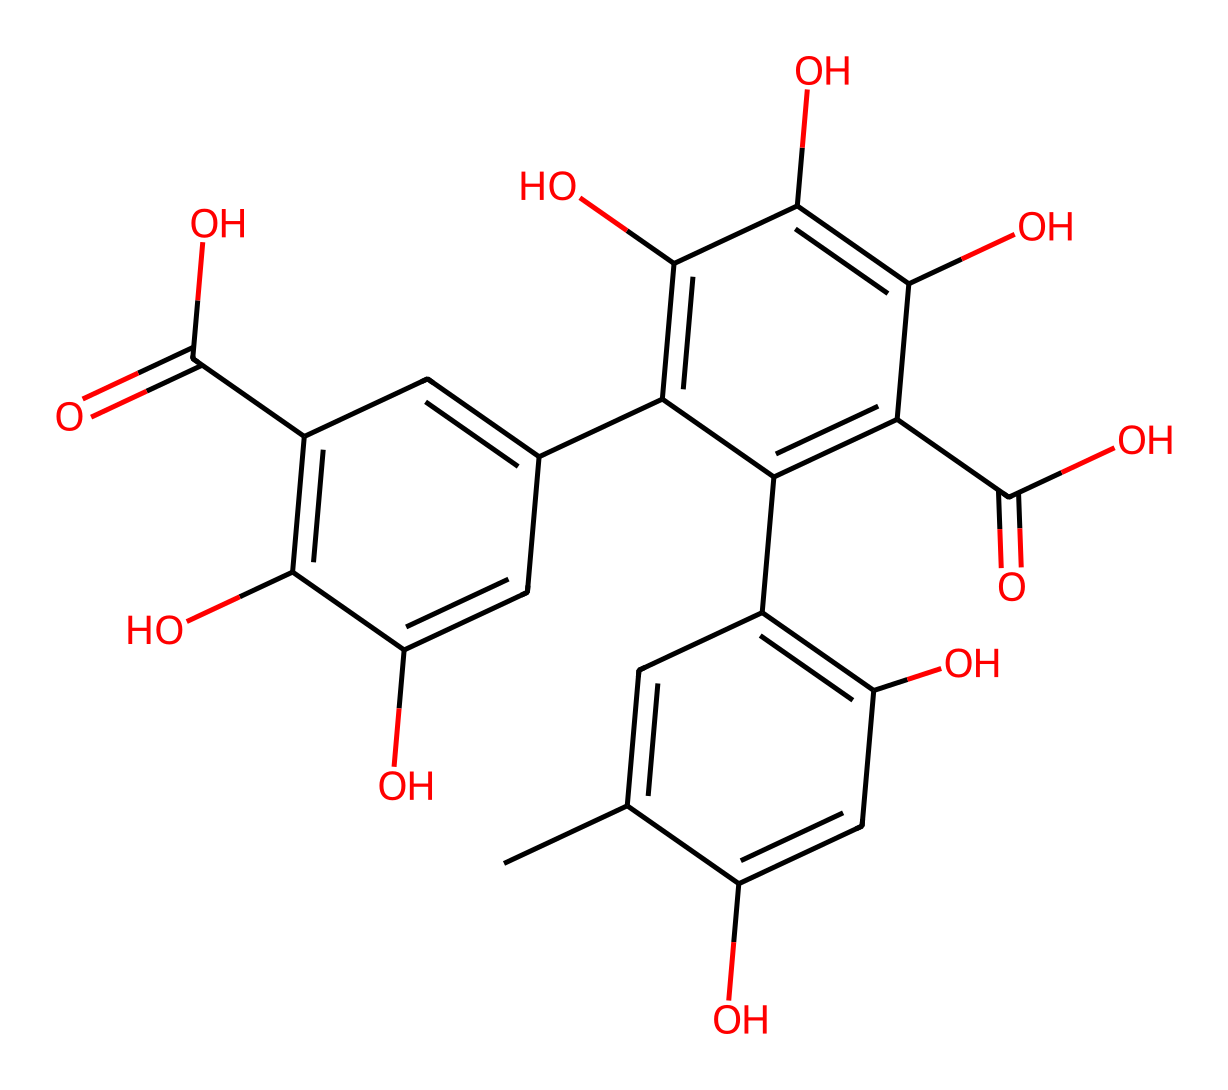what is the total number of carbon atoms in this structure? By analyzing the SMILES representation, we can count the number of 'C' notations present. There are 20 carbon atoms accounted for in the entire structure.
Answer: 20 how many hydroxyl (–OH) groups are present in this chemical? The structure shows multiple occurrences of the 'O' representing hydroxyl groups. Counting these, there are 6 hydroxyl groups present in total.
Answer: 6 is this compound a type of flavonoid? Tannins, like this one, are indeed recognized as polyphenolic compounds, commonly classified under the broad category of flavonoids due to their multiple hydroxyl groups bonded to a polycyclic structure.
Answer: yes what is the significance of the carboxylic acid functional groups in this structure? The carboxylic acid groups (–COOH) increase the compound's acidity, allowing it to interact more readily with polar solvents such as water, which is essential for its solubility and bioactivity. There are 4 such functional groups in its structure.
Answer: 4 does this chemical structure indicate the presence of a glycosidic bond? Upon reviewing the molecular structure, we can confirm that there are no glycosidic bonds present, as this type of bond typically involves a connection between a carbohydrate and another molecule, which is absent here.
Answer: no how does the molecular structure relate to the taste of tannins in whisky? The presence of multiple hydroxyl groups enhances the astringency and bitterness of tannins, impacting the flavor profile of whisky. The complex interactions between these groups and taste receptors contribute to the overall mouthfeel and flavor.
Answer: astringency and bitterness 